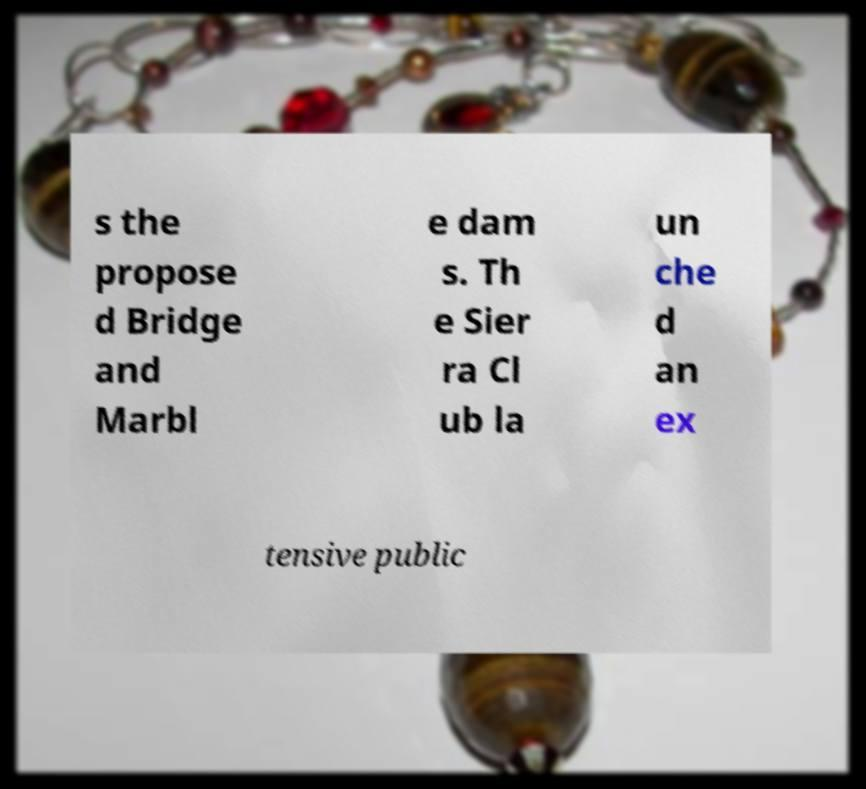Can you read and provide the text displayed in the image?This photo seems to have some interesting text. Can you extract and type it out for me? s the propose d Bridge and Marbl e dam s. Th e Sier ra Cl ub la un che d an ex tensive public 